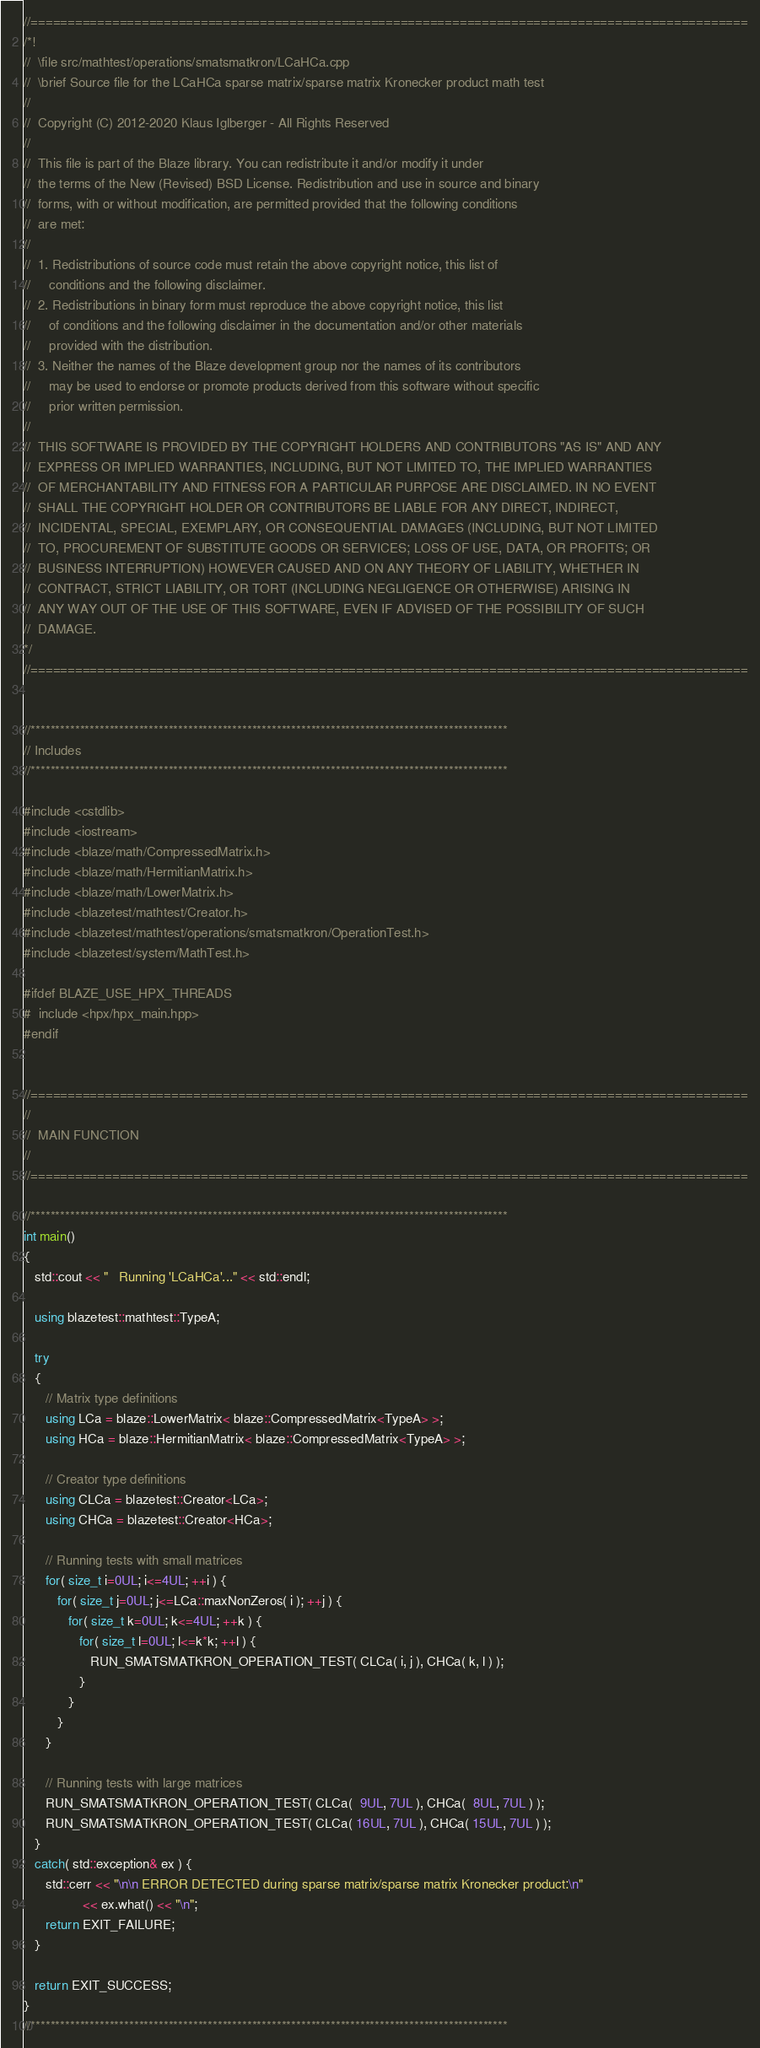Convert code to text. <code><loc_0><loc_0><loc_500><loc_500><_C++_>//=================================================================================================
/*!
//  \file src/mathtest/operations/smatsmatkron/LCaHCa.cpp
//  \brief Source file for the LCaHCa sparse matrix/sparse matrix Kronecker product math test
//
//  Copyright (C) 2012-2020 Klaus Iglberger - All Rights Reserved
//
//  This file is part of the Blaze library. You can redistribute it and/or modify it under
//  the terms of the New (Revised) BSD License. Redistribution and use in source and binary
//  forms, with or without modification, are permitted provided that the following conditions
//  are met:
//
//  1. Redistributions of source code must retain the above copyright notice, this list of
//     conditions and the following disclaimer.
//  2. Redistributions in binary form must reproduce the above copyright notice, this list
//     of conditions and the following disclaimer in the documentation and/or other materials
//     provided with the distribution.
//  3. Neither the names of the Blaze development group nor the names of its contributors
//     may be used to endorse or promote products derived from this software without specific
//     prior written permission.
//
//  THIS SOFTWARE IS PROVIDED BY THE COPYRIGHT HOLDERS AND CONTRIBUTORS "AS IS" AND ANY
//  EXPRESS OR IMPLIED WARRANTIES, INCLUDING, BUT NOT LIMITED TO, THE IMPLIED WARRANTIES
//  OF MERCHANTABILITY AND FITNESS FOR A PARTICULAR PURPOSE ARE DISCLAIMED. IN NO EVENT
//  SHALL THE COPYRIGHT HOLDER OR CONTRIBUTORS BE LIABLE FOR ANY DIRECT, INDIRECT,
//  INCIDENTAL, SPECIAL, EXEMPLARY, OR CONSEQUENTIAL DAMAGES (INCLUDING, BUT NOT LIMITED
//  TO, PROCUREMENT OF SUBSTITUTE GOODS OR SERVICES; LOSS OF USE, DATA, OR PROFITS; OR
//  BUSINESS INTERRUPTION) HOWEVER CAUSED AND ON ANY THEORY OF LIABILITY, WHETHER IN
//  CONTRACT, STRICT LIABILITY, OR TORT (INCLUDING NEGLIGENCE OR OTHERWISE) ARISING IN
//  ANY WAY OUT OF THE USE OF THIS SOFTWARE, EVEN IF ADVISED OF THE POSSIBILITY OF SUCH
//  DAMAGE.
*/
//=================================================================================================


//*************************************************************************************************
// Includes
//*************************************************************************************************

#include <cstdlib>
#include <iostream>
#include <blaze/math/CompressedMatrix.h>
#include <blaze/math/HermitianMatrix.h>
#include <blaze/math/LowerMatrix.h>
#include <blazetest/mathtest/Creator.h>
#include <blazetest/mathtest/operations/smatsmatkron/OperationTest.h>
#include <blazetest/system/MathTest.h>

#ifdef BLAZE_USE_HPX_THREADS
#  include <hpx/hpx_main.hpp>
#endif


//=================================================================================================
//
//  MAIN FUNCTION
//
//=================================================================================================

//*************************************************************************************************
int main()
{
   std::cout << "   Running 'LCaHCa'..." << std::endl;

   using blazetest::mathtest::TypeA;

   try
   {
      // Matrix type definitions
      using LCa = blaze::LowerMatrix< blaze::CompressedMatrix<TypeA> >;
      using HCa = blaze::HermitianMatrix< blaze::CompressedMatrix<TypeA> >;

      // Creator type definitions
      using CLCa = blazetest::Creator<LCa>;
      using CHCa = blazetest::Creator<HCa>;

      // Running tests with small matrices
      for( size_t i=0UL; i<=4UL; ++i ) {
         for( size_t j=0UL; j<=LCa::maxNonZeros( i ); ++j ) {
            for( size_t k=0UL; k<=4UL; ++k ) {
               for( size_t l=0UL; l<=k*k; ++l ) {
                  RUN_SMATSMATKRON_OPERATION_TEST( CLCa( i, j ), CHCa( k, l ) );
               }
            }
         }
      }

      // Running tests with large matrices
      RUN_SMATSMATKRON_OPERATION_TEST( CLCa(  9UL, 7UL ), CHCa(  8UL, 7UL ) );
      RUN_SMATSMATKRON_OPERATION_TEST( CLCa( 16UL, 7UL ), CHCa( 15UL, 7UL ) );
   }
   catch( std::exception& ex ) {
      std::cerr << "\n\n ERROR DETECTED during sparse matrix/sparse matrix Kronecker product:\n"
                << ex.what() << "\n";
      return EXIT_FAILURE;
   }

   return EXIT_SUCCESS;
}
//*************************************************************************************************
</code> 